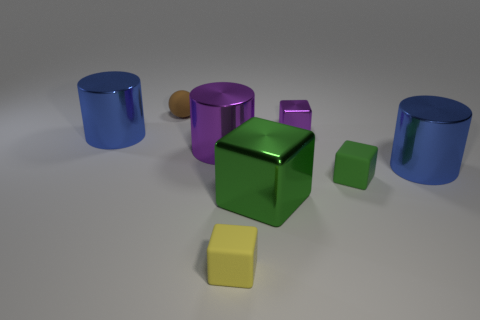There is a big blue shiny thing that is on the right side of the small object that is to the left of the yellow matte cube; what number of tiny things are behind it?
Offer a very short reply. 2. Is the number of yellow objects that are to the right of the yellow thing less than the number of brown shiny things?
Give a very brief answer. No. Is there anything else that has the same shape as the yellow object?
Your answer should be compact. Yes. There is a green object that is right of the tiny purple object; what shape is it?
Keep it short and to the point. Cube. There is a tiny matte thing right of the yellow cube that is left of the green object that is on the left side of the tiny purple block; what is its shape?
Make the answer very short. Cube. How many objects are green matte spheres or large objects?
Ensure brevity in your answer.  4. There is a blue metallic object behind the large purple shiny cylinder; is it the same shape as the yellow matte thing to the right of the brown matte thing?
Your response must be concise. No. How many big cylinders are left of the small brown matte thing and in front of the purple shiny cylinder?
Your answer should be very brief. 0. How many other objects are there of the same size as the brown object?
Ensure brevity in your answer.  3. There is a small thing that is to the left of the tiny purple metal object and on the right side of the purple shiny cylinder; what is its material?
Ensure brevity in your answer.  Rubber. 